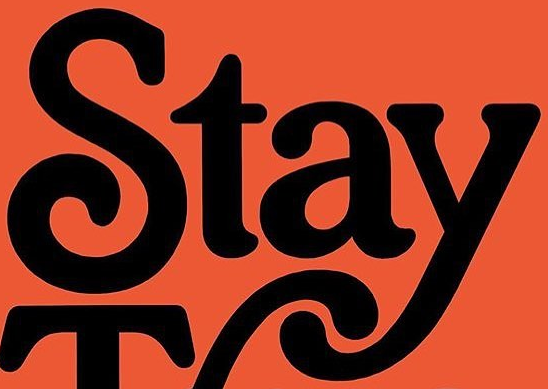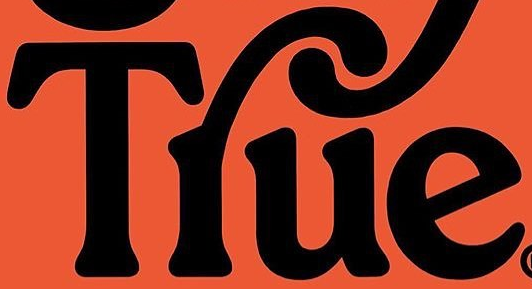What text appears in these images from left to right, separated by a semicolon? Stay; Tlue 